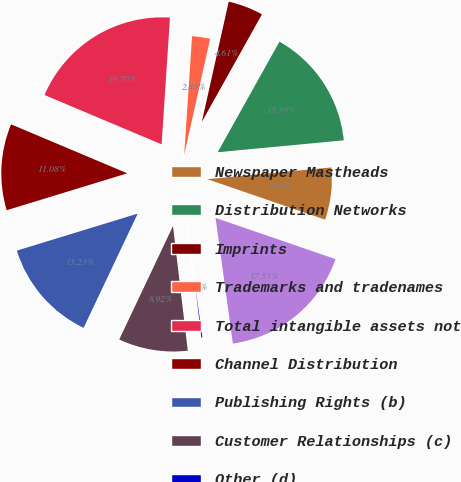<chart> <loc_0><loc_0><loc_500><loc_500><pie_chart><fcel>Newspaper Mastheads<fcel>Distribution Networks<fcel>Imprints<fcel>Trademarks and tradenames<fcel>Total intangible assets not<fcel>Channel Distribution<fcel>Publishing Rights (b)<fcel>Customer Relationships (c)<fcel>Other (d)<fcel>Total intangible assets<nl><fcel>6.77%<fcel>15.39%<fcel>4.61%<fcel>2.45%<fcel>19.7%<fcel>11.08%<fcel>13.23%<fcel>8.92%<fcel>0.3%<fcel>17.55%<nl></chart> 